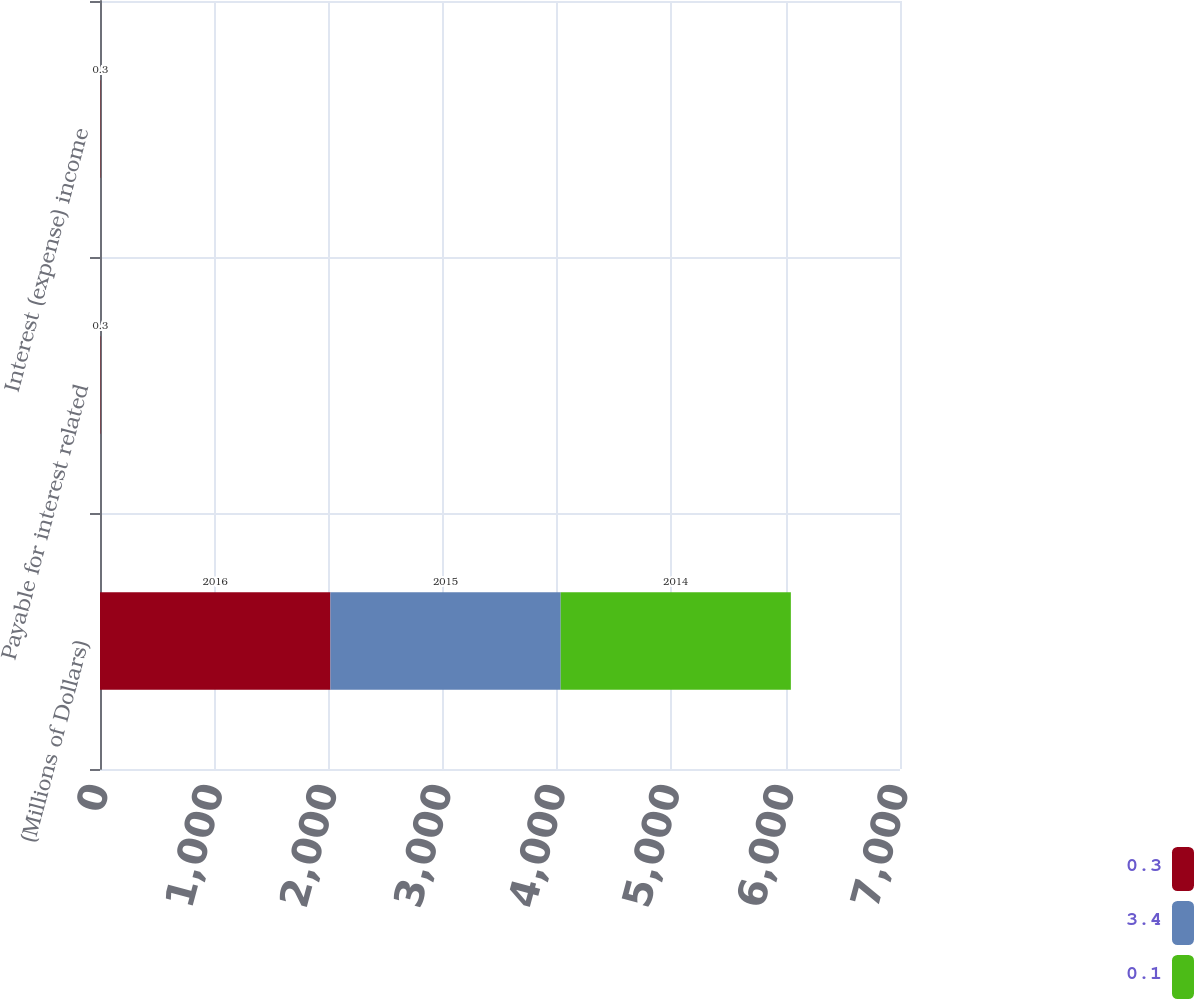Convert chart to OTSL. <chart><loc_0><loc_0><loc_500><loc_500><stacked_bar_chart><ecel><fcel>(Millions of Dollars)<fcel>Payable for interest related<fcel>Interest (expense) income<nl><fcel>0.3<fcel>2016<fcel>3.4<fcel>3.3<nl><fcel>3.4<fcel>2015<fcel>0.1<fcel>0.2<nl><fcel>0.1<fcel>2014<fcel>0.3<fcel>0.3<nl></chart> 